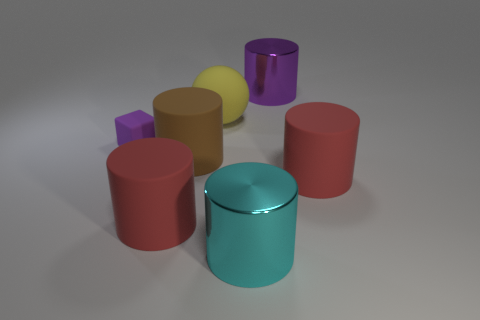There is a large red thing behind the red cylinder to the left of the yellow matte ball; what shape is it?
Provide a short and direct response. Cylinder. Are there any other things that are the same size as the purple shiny object?
Provide a succinct answer. Yes. What shape is the big red matte thing that is right of the big purple metallic cylinder that is to the right of the metallic cylinder in front of the matte ball?
Your response must be concise. Cylinder. How many objects are either cylinders that are behind the tiny purple block or matte things right of the brown cylinder?
Keep it short and to the point. 3. There is a purple rubber thing; does it have the same size as the purple thing that is on the right side of the big yellow object?
Offer a terse response. No. Is the purple object that is on the right side of the purple rubber object made of the same material as the big red cylinder that is to the right of the cyan metal thing?
Offer a very short reply. No. Is the number of red things that are right of the big brown cylinder the same as the number of large yellow matte things to the right of the big cyan metallic thing?
Offer a very short reply. No. How many other big spheres have the same color as the matte sphere?
Keep it short and to the point. 0. There is a large object that is the same color as the tiny rubber object; what material is it?
Give a very brief answer. Metal. How many metallic things are either purple cylinders or red cubes?
Offer a terse response. 1. 